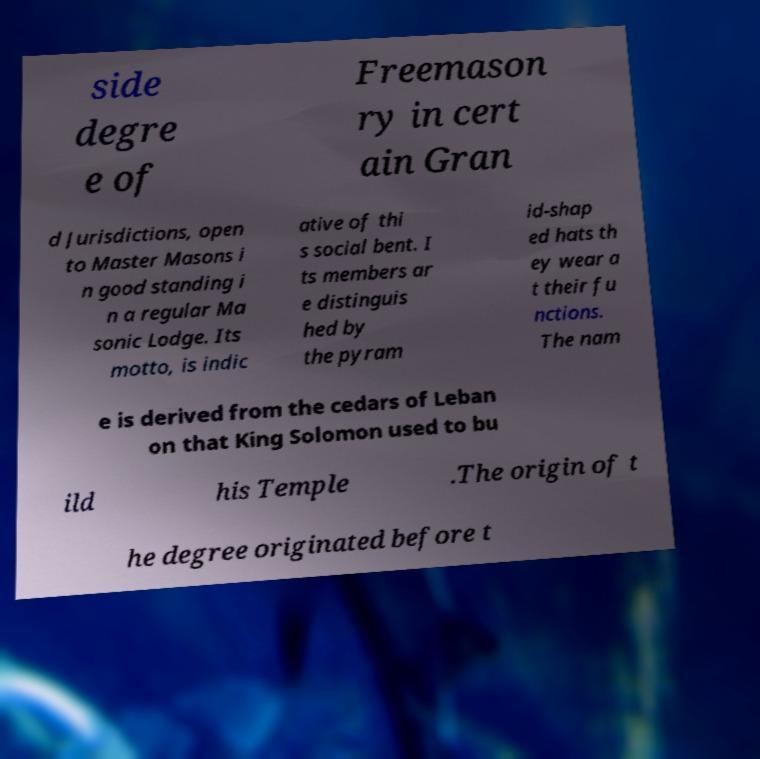What messages or text are displayed in this image? I need them in a readable, typed format. side degre e of Freemason ry in cert ain Gran d Jurisdictions, open to Master Masons i n good standing i n a regular Ma sonic Lodge. Its motto, is indic ative of thi s social bent. I ts members ar e distinguis hed by the pyram id-shap ed hats th ey wear a t their fu nctions. The nam e is derived from the cedars of Leban on that King Solomon used to bu ild his Temple .The origin of t he degree originated before t 